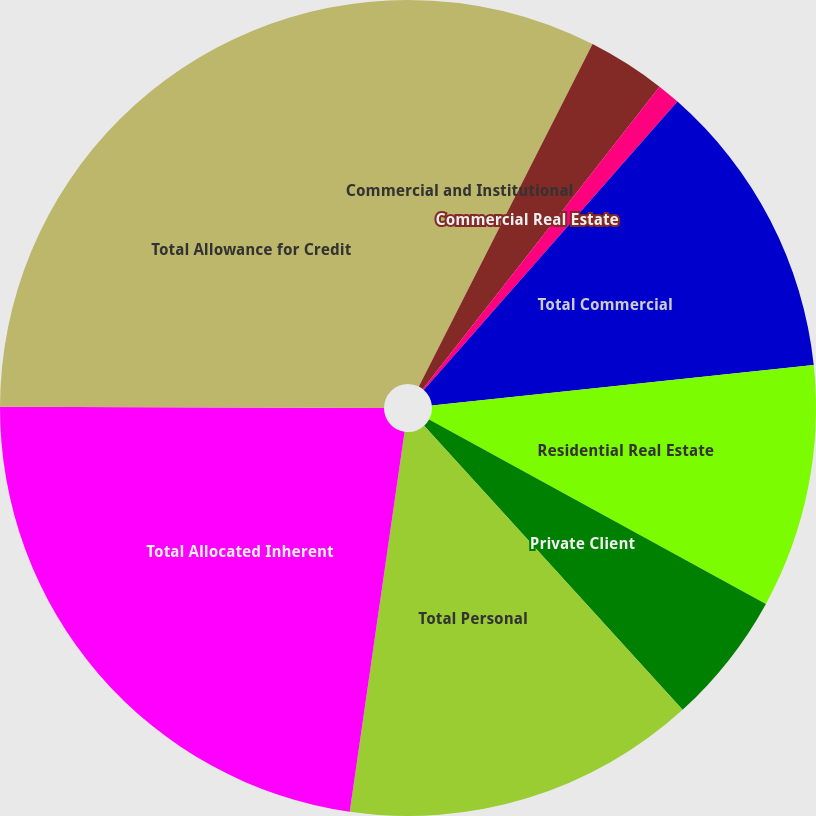Convert chart. <chart><loc_0><loc_0><loc_500><loc_500><pie_chart><fcel>Commercial and Institutional<fcel>Commercial Real Estate<fcel>Lease Financing net<fcel>Total Commercial<fcel>Residential Real Estate<fcel>Private Client<fcel>Total Personal<fcel>Total Allocated Inherent<fcel>Total Allowance for Credit<nl><fcel>7.47%<fcel>3.1%<fcel>0.91%<fcel>11.84%<fcel>9.65%<fcel>5.28%<fcel>14.03%<fcel>22.77%<fcel>24.95%<nl></chart> 